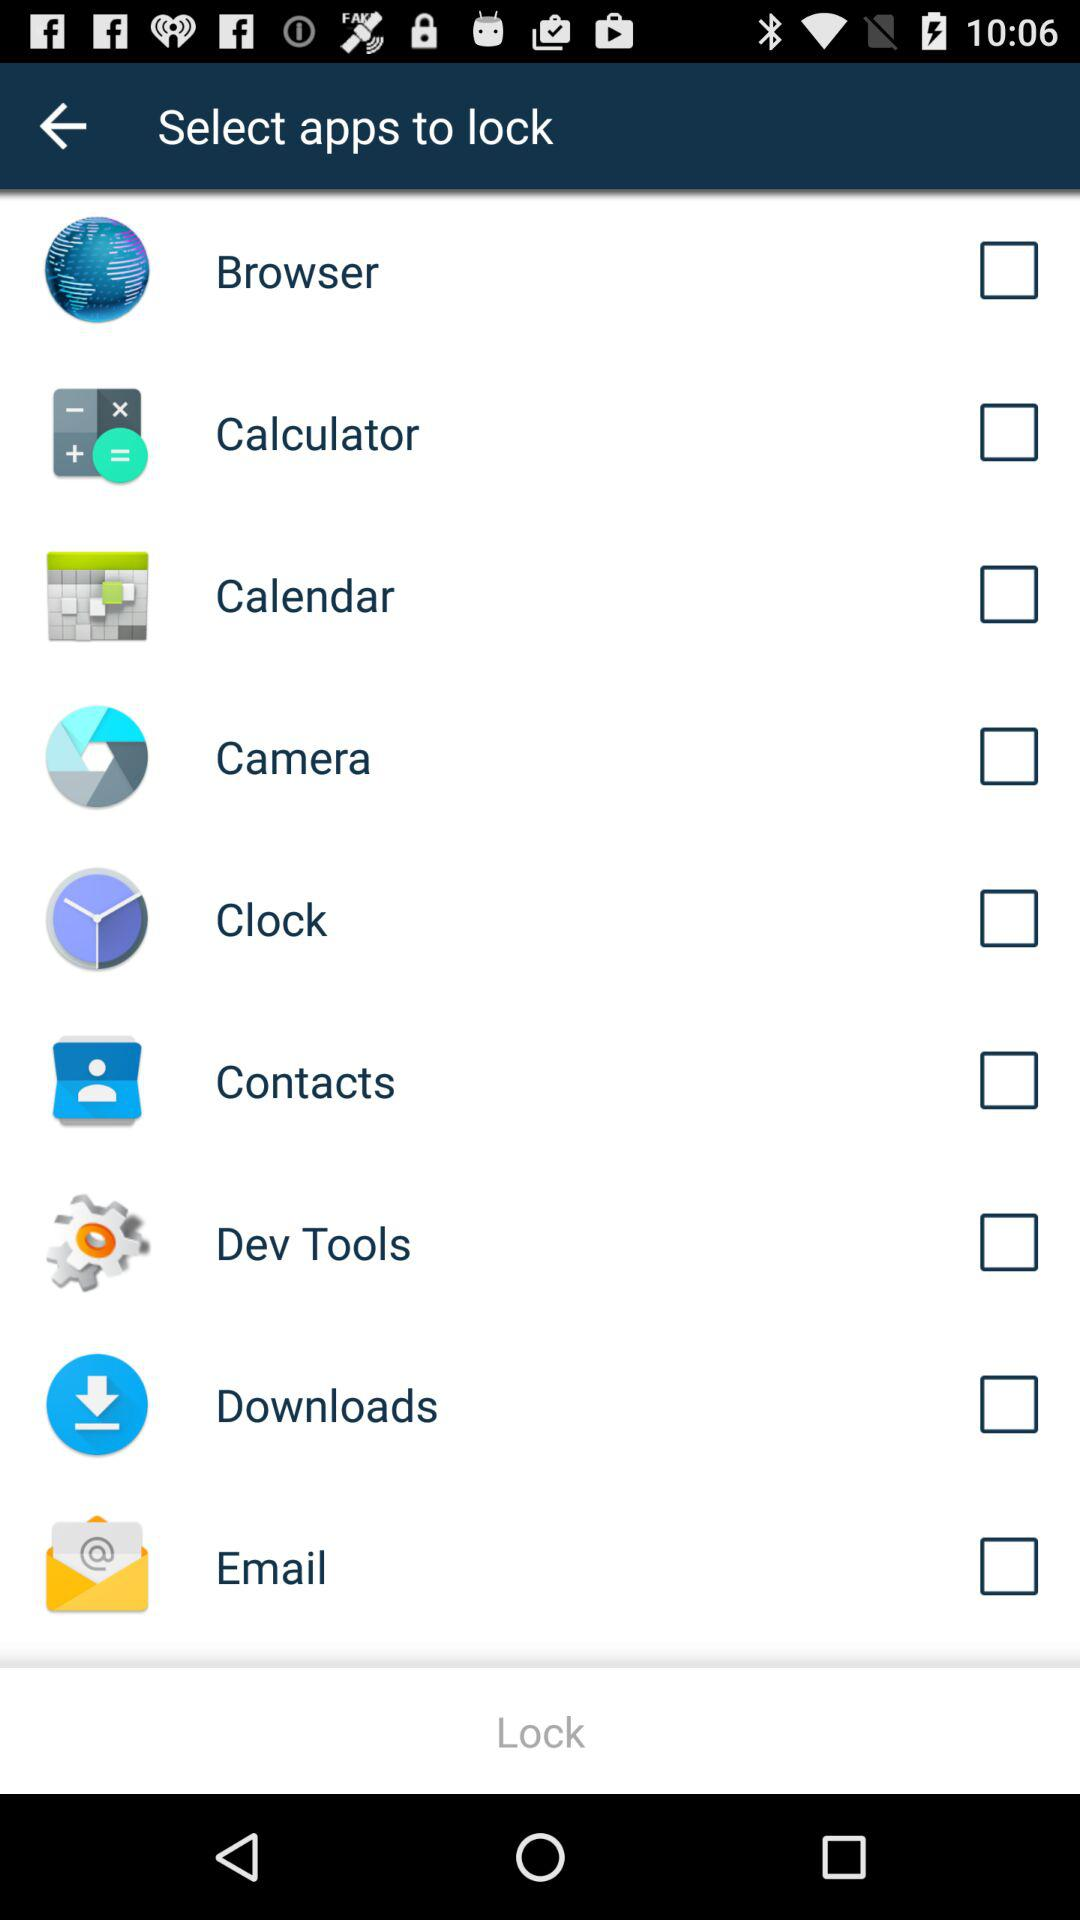What is the status of "Calculator"? The status of "Calculator" is "off". 